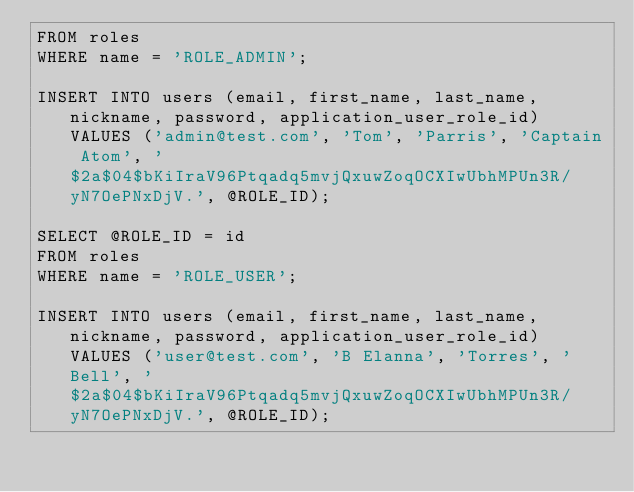<code> <loc_0><loc_0><loc_500><loc_500><_SQL_>FROM roles
WHERE name = 'ROLE_ADMIN';

INSERT INTO users (email, first_name, last_name, nickname, password, application_user_role_id) VALUES ('admin@test.com', 'Tom', 'Parris', 'Captain Atom', '$2a$04$bKiIraV96Ptqadq5mvjQxuwZoqOCXIwUbhMPUn3R/yN7OePNxDjV.', @ROLE_ID);

SELECT @ROLE_ID = id
FROM roles
WHERE name = 'ROLE_USER';

INSERT INTO users (email, first_name, last_name, nickname, password, application_user_role_id) VALUES ('user@test.com', 'B Elanna', 'Torres', 'Bell', '$2a$04$bKiIraV96Ptqadq5mvjQxuwZoqOCXIwUbhMPUn3R/yN7OePNxDjV.', @ROLE_ID);</code> 